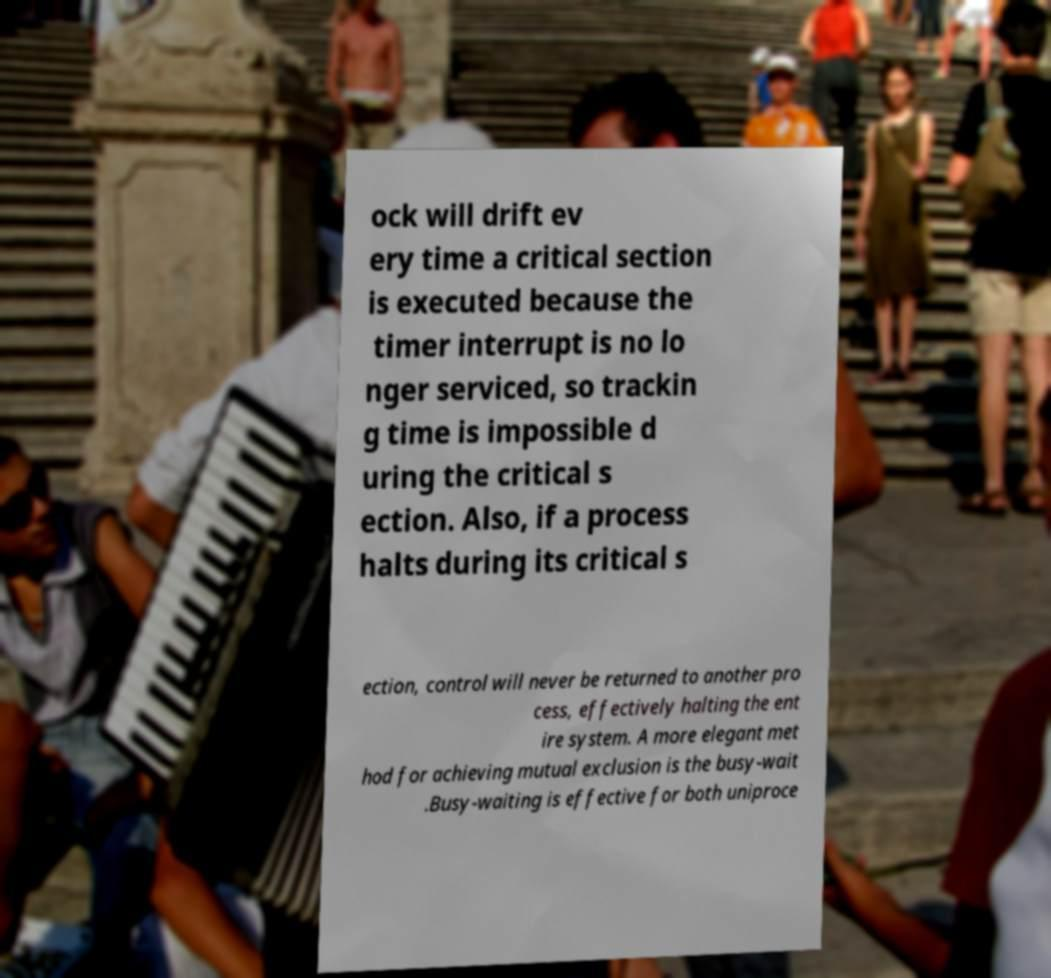Could you assist in decoding the text presented in this image and type it out clearly? ock will drift ev ery time a critical section is executed because the timer interrupt is no lo nger serviced, so trackin g time is impossible d uring the critical s ection. Also, if a process halts during its critical s ection, control will never be returned to another pro cess, effectively halting the ent ire system. A more elegant met hod for achieving mutual exclusion is the busy-wait .Busy-waiting is effective for both uniproce 